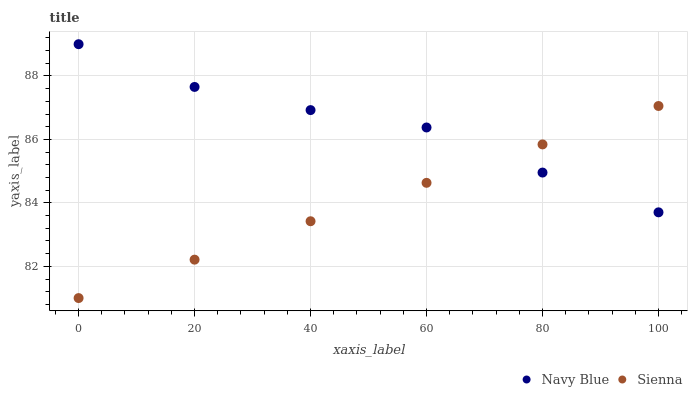Does Sienna have the minimum area under the curve?
Answer yes or no. Yes. Does Navy Blue have the maximum area under the curve?
Answer yes or no. Yes. Does Navy Blue have the minimum area under the curve?
Answer yes or no. No. Is Sienna the smoothest?
Answer yes or no. Yes. Is Navy Blue the roughest?
Answer yes or no. Yes. Is Navy Blue the smoothest?
Answer yes or no. No. Does Sienna have the lowest value?
Answer yes or no. Yes. Does Navy Blue have the lowest value?
Answer yes or no. No. Does Navy Blue have the highest value?
Answer yes or no. Yes. Does Navy Blue intersect Sienna?
Answer yes or no. Yes. Is Navy Blue less than Sienna?
Answer yes or no. No. Is Navy Blue greater than Sienna?
Answer yes or no. No. 